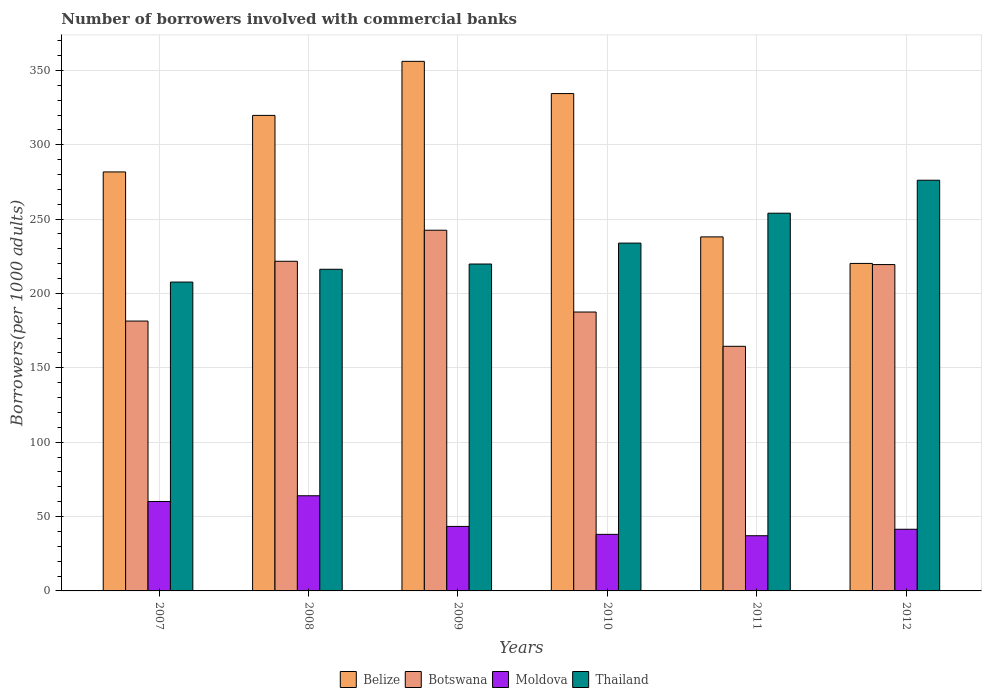How many groups of bars are there?
Your response must be concise. 6. Are the number of bars per tick equal to the number of legend labels?
Ensure brevity in your answer.  Yes. Are the number of bars on each tick of the X-axis equal?
Provide a short and direct response. Yes. What is the number of borrowers involved with commercial banks in Thailand in 2011?
Offer a terse response. 253.97. Across all years, what is the maximum number of borrowers involved with commercial banks in Belize?
Provide a succinct answer. 356.07. Across all years, what is the minimum number of borrowers involved with commercial banks in Botswana?
Provide a succinct answer. 164.48. In which year was the number of borrowers involved with commercial banks in Botswana maximum?
Your answer should be very brief. 2009. What is the total number of borrowers involved with commercial banks in Moldova in the graph?
Give a very brief answer. 284.11. What is the difference between the number of borrowers involved with commercial banks in Botswana in 2011 and that in 2012?
Provide a short and direct response. -54.96. What is the difference between the number of borrowers involved with commercial banks in Belize in 2008 and the number of borrowers involved with commercial banks in Moldova in 2009?
Provide a succinct answer. 276.36. What is the average number of borrowers involved with commercial banks in Thailand per year?
Ensure brevity in your answer.  234.62. In the year 2009, what is the difference between the number of borrowers involved with commercial banks in Botswana and number of borrowers involved with commercial banks in Moldova?
Ensure brevity in your answer.  199.15. What is the ratio of the number of borrowers involved with commercial banks in Thailand in 2009 to that in 2010?
Give a very brief answer. 0.94. What is the difference between the highest and the second highest number of borrowers involved with commercial banks in Moldova?
Ensure brevity in your answer.  3.86. What is the difference between the highest and the lowest number of borrowers involved with commercial banks in Botswana?
Make the answer very short. 78.04. In how many years, is the number of borrowers involved with commercial banks in Thailand greater than the average number of borrowers involved with commercial banks in Thailand taken over all years?
Keep it short and to the point. 2. Is it the case that in every year, the sum of the number of borrowers involved with commercial banks in Botswana and number of borrowers involved with commercial banks in Thailand is greater than the sum of number of borrowers involved with commercial banks in Belize and number of borrowers involved with commercial banks in Moldova?
Your answer should be very brief. Yes. What does the 1st bar from the left in 2009 represents?
Your response must be concise. Belize. What does the 1st bar from the right in 2010 represents?
Provide a short and direct response. Thailand. Are all the bars in the graph horizontal?
Give a very brief answer. No. How many years are there in the graph?
Provide a succinct answer. 6. Are the values on the major ticks of Y-axis written in scientific E-notation?
Offer a terse response. No. Does the graph contain any zero values?
Keep it short and to the point. No. What is the title of the graph?
Offer a terse response. Number of borrowers involved with commercial banks. Does "Bosnia and Herzegovina" appear as one of the legend labels in the graph?
Keep it short and to the point. No. What is the label or title of the Y-axis?
Give a very brief answer. Borrowers(per 1000 adults). What is the Borrowers(per 1000 adults) of Belize in 2007?
Keep it short and to the point. 281.72. What is the Borrowers(per 1000 adults) of Botswana in 2007?
Provide a succinct answer. 181.45. What is the Borrowers(per 1000 adults) of Moldova in 2007?
Provide a succinct answer. 60.13. What is the Borrowers(per 1000 adults) in Thailand in 2007?
Make the answer very short. 207.67. What is the Borrowers(per 1000 adults) in Belize in 2008?
Give a very brief answer. 319.74. What is the Borrowers(per 1000 adults) of Botswana in 2008?
Give a very brief answer. 221.65. What is the Borrowers(per 1000 adults) in Moldova in 2008?
Offer a very short reply. 63.99. What is the Borrowers(per 1000 adults) of Thailand in 2008?
Keep it short and to the point. 216.28. What is the Borrowers(per 1000 adults) in Belize in 2009?
Keep it short and to the point. 356.07. What is the Borrowers(per 1000 adults) of Botswana in 2009?
Ensure brevity in your answer.  242.52. What is the Borrowers(per 1000 adults) in Moldova in 2009?
Your answer should be very brief. 43.38. What is the Borrowers(per 1000 adults) of Thailand in 2009?
Your response must be concise. 219.81. What is the Borrowers(per 1000 adults) in Belize in 2010?
Give a very brief answer. 334.41. What is the Borrowers(per 1000 adults) of Botswana in 2010?
Provide a short and direct response. 187.53. What is the Borrowers(per 1000 adults) in Moldova in 2010?
Offer a very short reply. 38.03. What is the Borrowers(per 1000 adults) of Thailand in 2010?
Provide a short and direct response. 233.87. What is the Borrowers(per 1000 adults) in Belize in 2011?
Make the answer very short. 238.05. What is the Borrowers(per 1000 adults) of Botswana in 2011?
Provide a short and direct response. 164.48. What is the Borrowers(per 1000 adults) in Moldova in 2011?
Provide a succinct answer. 37.11. What is the Borrowers(per 1000 adults) of Thailand in 2011?
Provide a succinct answer. 253.97. What is the Borrowers(per 1000 adults) in Belize in 2012?
Your answer should be compact. 220.2. What is the Borrowers(per 1000 adults) in Botswana in 2012?
Your response must be concise. 219.44. What is the Borrowers(per 1000 adults) of Moldova in 2012?
Make the answer very short. 41.47. What is the Borrowers(per 1000 adults) of Thailand in 2012?
Your answer should be very brief. 276.15. Across all years, what is the maximum Borrowers(per 1000 adults) in Belize?
Provide a short and direct response. 356.07. Across all years, what is the maximum Borrowers(per 1000 adults) in Botswana?
Give a very brief answer. 242.52. Across all years, what is the maximum Borrowers(per 1000 adults) in Moldova?
Offer a very short reply. 63.99. Across all years, what is the maximum Borrowers(per 1000 adults) in Thailand?
Ensure brevity in your answer.  276.15. Across all years, what is the minimum Borrowers(per 1000 adults) of Belize?
Offer a very short reply. 220.2. Across all years, what is the minimum Borrowers(per 1000 adults) in Botswana?
Give a very brief answer. 164.48. Across all years, what is the minimum Borrowers(per 1000 adults) of Moldova?
Provide a succinct answer. 37.11. Across all years, what is the minimum Borrowers(per 1000 adults) in Thailand?
Offer a very short reply. 207.67. What is the total Borrowers(per 1000 adults) of Belize in the graph?
Keep it short and to the point. 1750.19. What is the total Borrowers(per 1000 adults) of Botswana in the graph?
Provide a short and direct response. 1217.07. What is the total Borrowers(per 1000 adults) of Moldova in the graph?
Your answer should be compact. 284.11. What is the total Borrowers(per 1000 adults) of Thailand in the graph?
Keep it short and to the point. 1407.74. What is the difference between the Borrowers(per 1000 adults) in Belize in 2007 and that in 2008?
Keep it short and to the point. -38.02. What is the difference between the Borrowers(per 1000 adults) of Botswana in 2007 and that in 2008?
Provide a short and direct response. -40.2. What is the difference between the Borrowers(per 1000 adults) of Moldova in 2007 and that in 2008?
Make the answer very short. -3.86. What is the difference between the Borrowers(per 1000 adults) in Thailand in 2007 and that in 2008?
Give a very brief answer. -8.6. What is the difference between the Borrowers(per 1000 adults) in Belize in 2007 and that in 2009?
Offer a terse response. -74.35. What is the difference between the Borrowers(per 1000 adults) of Botswana in 2007 and that in 2009?
Offer a terse response. -61.07. What is the difference between the Borrowers(per 1000 adults) of Moldova in 2007 and that in 2009?
Keep it short and to the point. 16.76. What is the difference between the Borrowers(per 1000 adults) of Thailand in 2007 and that in 2009?
Your answer should be very brief. -12.13. What is the difference between the Borrowers(per 1000 adults) of Belize in 2007 and that in 2010?
Your response must be concise. -52.68. What is the difference between the Borrowers(per 1000 adults) in Botswana in 2007 and that in 2010?
Offer a very short reply. -6.07. What is the difference between the Borrowers(per 1000 adults) of Moldova in 2007 and that in 2010?
Provide a short and direct response. 22.1. What is the difference between the Borrowers(per 1000 adults) of Thailand in 2007 and that in 2010?
Your answer should be compact. -26.2. What is the difference between the Borrowers(per 1000 adults) in Belize in 2007 and that in 2011?
Offer a terse response. 43.68. What is the difference between the Borrowers(per 1000 adults) in Botswana in 2007 and that in 2011?
Make the answer very short. 16.97. What is the difference between the Borrowers(per 1000 adults) of Moldova in 2007 and that in 2011?
Your response must be concise. 23.02. What is the difference between the Borrowers(per 1000 adults) of Thailand in 2007 and that in 2011?
Your answer should be compact. -46.3. What is the difference between the Borrowers(per 1000 adults) in Belize in 2007 and that in 2012?
Your answer should be very brief. 61.52. What is the difference between the Borrowers(per 1000 adults) in Botswana in 2007 and that in 2012?
Your answer should be very brief. -37.99. What is the difference between the Borrowers(per 1000 adults) of Moldova in 2007 and that in 2012?
Provide a short and direct response. 18.67. What is the difference between the Borrowers(per 1000 adults) in Thailand in 2007 and that in 2012?
Ensure brevity in your answer.  -68.48. What is the difference between the Borrowers(per 1000 adults) in Belize in 2008 and that in 2009?
Offer a very short reply. -36.33. What is the difference between the Borrowers(per 1000 adults) in Botswana in 2008 and that in 2009?
Provide a succinct answer. -20.87. What is the difference between the Borrowers(per 1000 adults) in Moldova in 2008 and that in 2009?
Your answer should be compact. 20.61. What is the difference between the Borrowers(per 1000 adults) of Thailand in 2008 and that in 2009?
Provide a succinct answer. -3.53. What is the difference between the Borrowers(per 1000 adults) in Belize in 2008 and that in 2010?
Make the answer very short. -14.67. What is the difference between the Borrowers(per 1000 adults) of Botswana in 2008 and that in 2010?
Offer a very short reply. 34.12. What is the difference between the Borrowers(per 1000 adults) in Moldova in 2008 and that in 2010?
Make the answer very short. 25.95. What is the difference between the Borrowers(per 1000 adults) in Thailand in 2008 and that in 2010?
Provide a succinct answer. -17.59. What is the difference between the Borrowers(per 1000 adults) of Belize in 2008 and that in 2011?
Your answer should be very brief. 81.69. What is the difference between the Borrowers(per 1000 adults) in Botswana in 2008 and that in 2011?
Give a very brief answer. 57.17. What is the difference between the Borrowers(per 1000 adults) of Moldova in 2008 and that in 2011?
Offer a very short reply. 26.87. What is the difference between the Borrowers(per 1000 adults) of Thailand in 2008 and that in 2011?
Keep it short and to the point. -37.7. What is the difference between the Borrowers(per 1000 adults) of Belize in 2008 and that in 2012?
Make the answer very short. 99.53. What is the difference between the Borrowers(per 1000 adults) of Botswana in 2008 and that in 2012?
Give a very brief answer. 2.21. What is the difference between the Borrowers(per 1000 adults) in Moldova in 2008 and that in 2012?
Make the answer very short. 22.52. What is the difference between the Borrowers(per 1000 adults) of Thailand in 2008 and that in 2012?
Give a very brief answer. -59.87. What is the difference between the Borrowers(per 1000 adults) of Belize in 2009 and that in 2010?
Offer a terse response. 21.67. What is the difference between the Borrowers(per 1000 adults) of Botswana in 2009 and that in 2010?
Your answer should be compact. 55. What is the difference between the Borrowers(per 1000 adults) of Moldova in 2009 and that in 2010?
Provide a short and direct response. 5.34. What is the difference between the Borrowers(per 1000 adults) in Thailand in 2009 and that in 2010?
Provide a short and direct response. -14.06. What is the difference between the Borrowers(per 1000 adults) in Belize in 2009 and that in 2011?
Offer a terse response. 118.03. What is the difference between the Borrowers(per 1000 adults) in Botswana in 2009 and that in 2011?
Offer a terse response. 78.04. What is the difference between the Borrowers(per 1000 adults) of Moldova in 2009 and that in 2011?
Your answer should be very brief. 6.26. What is the difference between the Borrowers(per 1000 adults) in Thailand in 2009 and that in 2011?
Your answer should be compact. -34.17. What is the difference between the Borrowers(per 1000 adults) of Belize in 2009 and that in 2012?
Your answer should be very brief. 135.87. What is the difference between the Borrowers(per 1000 adults) of Botswana in 2009 and that in 2012?
Provide a short and direct response. 23.08. What is the difference between the Borrowers(per 1000 adults) of Moldova in 2009 and that in 2012?
Keep it short and to the point. 1.91. What is the difference between the Borrowers(per 1000 adults) of Thailand in 2009 and that in 2012?
Provide a short and direct response. -56.34. What is the difference between the Borrowers(per 1000 adults) in Belize in 2010 and that in 2011?
Your response must be concise. 96.36. What is the difference between the Borrowers(per 1000 adults) in Botswana in 2010 and that in 2011?
Keep it short and to the point. 23.05. What is the difference between the Borrowers(per 1000 adults) in Moldova in 2010 and that in 2011?
Make the answer very short. 0.92. What is the difference between the Borrowers(per 1000 adults) of Thailand in 2010 and that in 2011?
Your answer should be compact. -20.1. What is the difference between the Borrowers(per 1000 adults) of Belize in 2010 and that in 2012?
Provide a succinct answer. 114.2. What is the difference between the Borrowers(per 1000 adults) in Botswana in 2010 and that in 2012?
Provide a succinct answer. -31.91. What is the difference between the Borrowers(per 1000 adults) in Moldova in 2010 and that in 2012?
Give a very brief answer. -3.43. What is the difference between the Borrowers(per 1000 adults) in Thailand in 2010 and that in 2012?
Give a very brief answer. -42.28. What is the difference between the Borrowers(per 1000 adults) in Belize in 2011 and that in 2012?
Offer a very short reply. 17.84. What is the difference between the Borrowers(per 1000 adults) of Botswana in 2011 and that in 2012?
Make the answer very short. -54.96. What is the difference between the Borrowers(per 1000 adults) in Moldova in 2011 and that in 2012?
Offer a terse response. -4.35. What is the difference between the Borrowers(per 1000 adults) in Thailand in 2011 and that in 2012?
Ensure brevity in your answer.  -22.18. What is the difference between the Borrowers(per 1000 adults) in Belize in 2007 and the Borrowers(per 1000 adults) in Botswana in 2008?
Keep it short and to the point. 60.07. What is the difference between the Borrowers(per 1000 adults) of Belize in 2007 and the Borrowers(per 1000 adults) of Moldova in 2008?
Offer a terse response. 217.73. What is the difference between the Borrowers(per 1000 adults) in Belize in 2007 and the Borrowers(per 1000 adults) in Thailand in 2008?
Make the answer very short. 65.45. What is the difference between the Borrowers(per 1000 adults) of Botswana in 2007 and the Borrowers(per 1000 adults) of Moldova in 2008?
Make the answer very short. 117.46. What is the difference between the Borrowers(per 1000 adults) of Botswana in 2007 and the Borrowers(per 1000 adults) of Thailand in 2008?
Your response must be concise. -34.82. What is the difference between the Borrowers(per 1000 adults) in Moldova in 2007 and the Borrowers(per 1000 adults) in Thailand in 2008?
Your answer should be very brief. -156.14. What is the difference between the Borrowers(per 1000 adults) in Belize in 2007 and the Borrowers(per 1000 adults) in Botswana in 2009?
Your response must be concise. 39.2. What is the difference between the Borrowers(per 1000 adults) in Belize in 2007 and the Borrowers(per 1000 adults) in Moldova in 2009?
Give a very brief answer. 238.35. What is the difference between the Borrowers(per 1000 adults) in Belize in 2007 and the Borrowers(per 1000 adults) in Thailand in 2009?
Offer a terse response. 61.92. What is the difference between the Borrowers(per 1000 adults) in Botswana in 2007 and the Borrowers(per 1000 adults) in Moldova in 2009?
Your response must be concise. 138.08. What is the difference between the Borrowers(per 1000 adults) of Botswana in 2007 and the Borrowers(per 1000 adults) of Thailand in 2009?
Your answer should be very brief. -38.35. What is the difference between the Borrowers(per 1000 adults) of Moldova in 2007 and the Borrowers(per 1000 adults) of Thailand in 2009?
Ensure brevity in your answer.  -159.67. What is the difference between the Borrowers(per 1000 adults) in Belize in 2007 and the Borrowers(per 1000 adults) in Botswana in 2010?
Your answer should be very brief. 94.2. What is the difference between the Borrowers(per 1000 adults) in Belize in 2007 and the Borrowers(per 1000 adults) in Moldova in 2010?
Make the answer very short. 243.69. What is the difference between the Borrowers(per 1000 adults) in Belize in 2007 and the Borrowers(per 1000 adults) in Thailand in 2010?
Provide a short and direct response. 47.85. What is the difference between the Borrowers(per 1000 adults) in Botswana in 2007 and the Borrowers(per 1000 adults) in Moldova in 2010?
Keep it short and to the point. 143.42. What is the difference between the Borrowers(per 1000 adults) of Botswana in 2007 and the Borrowers(per 1000 adults) of Thailand in 2010?
Make the answer very short. -52.42. What is the difference between the Borrowers(per 1000 adults) in Moldova in 2007 and the Borrowers(per 1000 adults) in Thailand in 2010?
Provide a short and direct response. -173.74. What is the difference between the Borrowers(per 1000 adults) of Belize in 2007 and the Borrowers(per 1000 adults) of Botswana in 2011?
Your answer should be very brief. 117.24. What is the difference between the Borrowers(per 1000 adults) of Belize in 2007 and the Borrowers(per 1000 adults) of Moldova in 2011?
Offer a very short reply. 244.61. What is the difference between the Borrowers(per 1000 adults) in Belize in 2007 and the Borrowers(per 1000 adults) in Thailand in 2011?
Your response must be concise. 27.75. What is the difference between the Borrowers(per 1000 adults) in Botswana in 2007 and the Borrowers(per 1000 adults) in Moldova in 2011?
Give a very brief answer. 144.34. What is the difference between the Borrowers(per 1000 adults) of Botswana in 2007 and the Borrowers(per 1000 adults) of Thailand in 2011?
Provide a succinct answer. -72.52. What is the difference between the Borrowers(per 1000 adults) in Moldova in 2007 and the Borrowers(per 1000 adults) in Thailand in 2011?
Your answer should be very brief. -193.84. What is the difference between the Borrowers(per 1000 adults) in Belize in 2007 and the Borrowers(per 1000 adults) in Botswana in 2012?
Ensure brevity in your answer.  62.28. What is the difference between the Borrowers(per 1000 adults) in Belize in 2007 and the Borrowers(per 1000 adults) in Moldova in 2012?
Your answer should be very brief. 240.26. What is the difference between the Borrowers(per 1000 adults) of Belize in 2007 and the Borrowers(per 1000 adults) of Thailand in 2012?
Offer a very short reply. 5.57. What is the difference between the Borrowers(per 1000 adults) of Botswana in 2007 and the Borrowers(per 1000 adults) of Moldova in 2012?
Make the answer very short. 139.99. What is the difference between the Borrowers(per 1000 adults) in Botswana in 2007 and the Borrowers(per 1000 adults) in Thailand in 2012?
Ensure brevity in your answer.  -94.7. What is the difference between the Borrowers(per 1000 adults) in Moldova in 2007 and the Borrowers(per 1000 adults) in Thailand in 2012?
Offer a terse response. -216.01. What is the difference between the Borrowers(per 1000 adults) in Belize in 2008 and the Borrowers(per 1000 adults) in Botswana in 2009?
Make the answer very short. 77.22. What is the difference between the Borrowers(per 1000 adults) of Belize in 2008 and the Borrowers(per 1000 adults) of Moldova in 2009?
Ensure brevity in your answer.  276.36. What is the difference between the Borrowers(per 1000 adults) in Belize in 2008 and the Borrowers(per 1000 adults) in Thailand in 2009?
Offer a terse response. 99.93. What is the difference between the Borrowers(per 1000 adults) of Botswana in 2008 and the Borrowers(per 1000 adults) of Moldova in 2009?
Provide a short and direct response. 178.27. What is the difference between the Borrowers(per 1000 adults) in Botswana in 2008 and the Borrowers(per 1000 adults) in Thailand in 2009?
Provide a short and direct response. 1.84. What is the difference between the Borrowers(per 1000 adults) of Moldova in 2008 and the Borrowers(per 1000 adults) of Thailand in 2009?
Make the answer very short. -155.82. What is the difference between the Borrowers(per 1000 adults) of Belize in 2008 and the Borrowers(per 1000 adults) of Botswana in 2010?
Your response must be concise. 132.21. What is the difference between the Borrowers(per 1000 adults) of Belize in 2008 and the Borrowers(per 1000 adults) of Moldova in 2010?
Ensure brevity in your answer.  281.7. What is the difference between the Borrowers(per 1000 adults) of Belize in 2008 and the Borrowers(per 1000 adults) of Thailand in 2010?
Make the answer very short. 85.87. What is the difference between the Borrowers(per 1000 adults) in Botswana in 2008 and the Borrowers(per 1000 adults) in Moldova in 2010?
Give a very brief answer. 183.62. What is the difference between the Borrowers(per 1000 adults) of Botswana in 2008 and the Borrowers(per 1000 adults) of Thailand in 2010?
Give a very brief answer. -12.22. What is the difference between the Borrowers(per 1000 adults) in Moldova in 2008 and the Borrowers(per 1000 adults) in Thailand in 2010?
Offer a terse response. -169.88. What is the difference between the Borrowers(per 1000 adults) in Belize in 2008 and the Borrowers(per 1000 adults) in Botswana in 2011?
Provide a succinct answer. 155.26. What is the difference between the Borrowers(per 1000 adults) of Belize in 2008 and the Borrowers(per 1000 adults) of Moldova in 2011?
Make the answer very short. 282.62. What is the difference between the Borrowers(per 1000 adults) in Belize in 2008 and the Borrowers(per 1000 adults) in Thailand in 2011?
Ensure brevity in your answer.  65.77. What is the difference between the Borrowers(per 1000 adults) in Botswana in 2008 and the Borrowers(per 1000 adults) in Moldova in 2011?
Keep it short and to the point. 184.54. What is the difference between the Borrowers(per 1000 adults) in Botswana in 2008 and the Borrowers(per 1000 adults) in Thailand in 2011?
Provide a succinct answer. -32.32. What is the difference between the Borrowers(per 1000 adults) of Moldova in 2008 and the Borrowers(per 1000 adults) of Thailand in 2011?
Your answer should be compact. -189.98. What is the difference between the Borrowers(per 1000 adults) of Belize in 2008 and the Borrowers(per 1000 adults) of Botswana in 2012?
Your answer should be very brief. 100.3. What is the difference between the Borrowers(per 1000 adults) of Belize in 2008 and the Borrowers(per 1000 adults) of Moldova in 2012?
Your answer should be very brief. 278.27. What is the difference between the Borrowers(per 1000 adults) in Belize in 2008 and the Borrowers(per 1000 adults) in Thailand in 2012?
Ensure brevity in your answer.  43.59. What is the difference between the Borrowers(per 1000 adults) in Botswana in 2008 and the Borrowers(per 1000 adults) in Moldova in 2012?
Give a very brief answer. 180.18. What is the difference between the Borrowers(per 1000 adults) of Botswana in 2008 and the Borrowers(per 1000 adults) of Thailand in 2012?
Offer a very short reply. -54.5. What is the difference between the Borrowers(per 1000 adults) of Moldova in 2008 and the Borrowers(per 1000 adults) of Thailand in 2012?
Offer a very short reply. -212.16. What is the difference between the Borrowers(per 1000 adults) in Belize in 2009 and the Borrowers(per 1000 adults) in Botswana in 2010?
Give a very brief answer. 168.54. What is the difference between the Borrowers(per 1000 adults) of Belize in 2009 and the Borrowers(per 1000 adults) of Moldova in 2010?
Ensure brevity in your answer.  318.04. What is the difference between the Borrowers(per 1000 adults) of Belize in 2009 and the Borrowers(per 1000 adults) of Thailand in 2010?
Your answer should be very brief. 122.2. What is the difference between the Borrowers(per 1000 adults) of Botswana in 2009 and the Borrowers(per 1000 adults) of Moldova in 2010?
Keep it short and to the point. 204.49. What is the difference between the Borrowers(per 1000 adults) in Botswana in 2009 and the Borrowers(per 1000 adults) in Thailand in 2010?
Your answer should be very brief. 8.65. What is the difference between the Borrowers(per 1000 adults) in Moldova in 2009 and the Borrowers(per 1000 adults) in Thailand in 2010?
Offer a terse response. -190.49. What is the difference between the Borrowers(per 1000 adults) in Belize in 2009 and the Borrowers(per 1000 adults) in Botswana in 2011?
Your answer should be very brief. 191.59. What is the difference between the Borrowers(per 1000 adults) in Belize in 2009 and the Borrowers(per 1000 adults) in Moldova in 2011?
Give a very brief answer. 318.96. What is the difference between the Borrowers(per 1000 adults) in Belize in 2009 and the Borrowers(per 1000 adults) in Thailand in 2011?
Offer a very short reply. 102.1. What is the difference between the Borrowers(per 1000 adults) of Botswana in 2009 and the Borrowers(per 1000 adults) of Moldova in 2011?
Your answer should be compact. 205.41. What is the difference between the Borrowers(per 1000 adults) in Botswana in 2009 and the Borrowers(per 1000 adults) in Thailand in 2011?
Your answer should be very brief. -11.45. What is the difference between the Borrowers(per 1000 adults) in Moldova in 2009 and the Borrowers(per 1000 adults) in Thailand in 2011?
Offer a very short reply. -210.59. What is the difference between the Borrowers(per 1000 adults) in Belize in 2009 and the Borrowers(per 1000 adults) in Botswana in 2012?
Provide a succinct answer. 136.63. What is the difference between the Borrowers(per 1000 adults) in Belize in 2009 and the Borrowers(per 1000 adults) in Moldova in 2012?
Keep it short and to the point. 314.61. What is the difference between the Borrowers(per 1000 adults) of Belize in 2009 and the Borrowers(per 1000 adults) of Thailand in 2012?
Make the answer very short. 79.92. What is the difference between the Borrowers(per 1000 adults) in Botswana in 2009 and the Borrowers(per 1000 adults) in Moldova in 2012?
Ensure brevity in your answer.  201.06. What is the difference between the Borrowers(per 1000 adults) of Botswana in 2009 and the Borrowers(per 1000 adults) of Thailand in 2012?
Ensure brevity in your answer.  -33.63. What is the difference between the Borrowers(per 1000 adults) of Moldova in 2009 and the Borrowers(per 1000 adults) of Thailand in 2012?
Provide a short and direct response. -232.77. What is the difference between the Borrowers(per 1000 adults) of Belize in 2010 and the Borrowers(per 1000 adults) of Botswana in 2011?
Provide a succinct answer. 169.93. What is the difference between the Borrowers(per 1000 adults) in Belize in 2010 and the Borrowers(per 1000 adults) in Moldova in 2011?
Keep it short and to the point. 297.29. What is the difference between the Borrowers(per 1000 adults) of Belize in 2010 and the Borrowers(per 1000 adults) of Thailand in 2011?
Ensure brevity in your answer.  80.43. What is the difference between the Borrowers(per 1000 adults) in Botswana in 2010 and the Borrowers(per 1000 adults) in Moldova in 2011?
Keep it short and to the point. 150.41. What is the difference between the Borrowers(per 1000 adults) of Botswana in 2010 and the Borrowers(per 1000 adults) of Thailand in 2011?
Offer a terse response. -66.44. What is the difference between the Borrowers(per 1000 adults) in Moldova in 2010 and the Borrowers(per 1000 adults) in Thailand in 2011?
Keep it short and to the point. -215.94. What is the difference between the Borrowers(per 1000 adults) of Belize in 2010 and the Borrowers(per 1000 adults) of Botswana in 2012?
Give a very brief answer. 114.97. What is the difference between the Borrowers(per 1000 adults) of Belize in 2010 and the Borrowers(per 1000 adults) of Moldova in 2012?
Provide a short and direct response. 292.94. What is the difference between the Borrowers(per 1000 adults) of Belize in 2010 and the Borrowers(per 1000 adults) of Thailand in 2012?
Ensure brevity in your answer.  58.26. What is the difference between the Borrowers(per 1000 adults) in Botswana in 2010 and the Borrowers(per 1000 adults) in Moldova in 2012?
Offer a very short reply. 146.06. What is the difference between the Borrowers(per 1000 adults) of Botswana in 2010 and the Borrowers(per 1000 adults) of Thailand in 2012?
Provide a succinct answer. -88.62. What is the difference between the Borrowers(per 1000 adults) in Moldova in 2010 and the Borrowers(per 1000 adults) in Thailand in 2012?
Make the answer very short. -238.11. What is the difference between the Borrowers(per 1000 adults) of Belize in 2011 and the Borrowers(per 1000 adults) of Botswana in 2012?
Offer a very short reply. 18.61. What is the difference between the Borrowers(per 1000 adults) of Belize in 2011 and the Borrowers(per 1000 adults) of Moldova in 2012?
Provide a succinct answer. 196.58. What is the difference between the Borrowers(per 1000 adults) of Belize in 2011 and the Borrowers(per 1000 adults) of Thailand in 2012?
Make the answer very short. -38.1. What is the difference between the Borrowers(per 1000 adults) in Botswana in 2011 and the Borrowers(per 1000 adults) in Moldova in 2012?
Offer a terse response. 123.01. What is the difference between the Borrowers(per 1000 adults) in Botswana in 2011 and the Borrowers(per 1000 adults) in Thailand in 2012?
Ensure brevity in your answer.  -111.67. What is the difference between the Borrowers(per 1000 adults) of Moldova in 2011 and the Borrowers(per 1000 adults) of Thailand in 2012?
Give a very brief answer. -239.03. What is the average Borrowers(per 1000 adults) in Belize per year?
Give a very brief answer. 291.7. What is the average Borrowers(per 1000 adults) of Botswana per year?
Your response must be concise. 202.84. What is the average Borrowers(per 1000 adults) of Moldova per year?
Provide a short and direct response. 47.35. What is the average Borrowers(per 1000 adults) in Thailand per year?
Provide a short and direct response. 234.62. In the year 2007, what is the difference between the Borrowers(per 1000 adults) in Belize and Borrowers(per 1000 adults) in Botswana?
Offer a terse response. 100.27. In the year 2007, what is the difference between the Borrowers(per 1000 adults) of Belize and Borrowers(per 1000 adults) of Moldova?
Provide a succinct answer. 221.59. In the year 2007, what is the difference between the Borrowers(per 1000 adults) of Belize and Borrowers(per 1000 adults) of Thailand?
Provide a short and direct response. 74.05. In the year 2007, what is the difference between the Borrowers(per 1000 adults) of Botswana and Borrowers(per 1000 adults) of Moldova?
Your answer should be very brief. 121.32. In the year 2007, what is the difference between the Borrowers(per 1000 adults) in Botswana and Borrowers(per 1000 adults) in Thailand?
Give a very brief answer. -26.22. In the year 2007, what is the difference between the Borrowers(per 1000 adults) in Moldova and Borrowers(per 1000 adults) in Thailand?
Give a very brief answer. -147.54. In the year 2008, what is the difference between the Borrowers(per 1000 adults) in Belize and Borrowers(per 1000 adults) in Botswana?
Your answer should be compact. 98.09. In the year 2008, what is the difference between the Borrowers(per 1000 adults) of Belize and Borrowers(per 1000 adults) of Moldova?
Your answer should be very brief. 255.75. In the year 2008, what is the difference between the Borrowers(per 1000 adults) in Belize and Borrowers(per 1000 adults) in Thailand?
Keep it short and to the point. 103.46. In the year 2008, what is the difference between the Borrowers(per 1000 adults) of Botswana and Borrowers(per 1000 adults) of Moldova?
Your answer should be very brief. 157.66. In the year 2008, what is the difference between the Borrowers(per 1000 adults) in Botswana and Borrowers(per 1000 adults) in Thailand?
Your response must be concise. 5.37. In the year 2008, what is the difference between the Borrowers(per 1000 adults) in Moldova and Borrowers(per 1000 adults) in Thailand?
Offer a very short reply. -152.29. In the year 2009, what is the difference between the Borrowers(per 1000 adults) of Belize and Borrowers(per 1000 adults) of Botswana?
Offer a terse response. 113.55. In the year 2009, what is the difference between the Borrowers(per 1000 adults) of Belize and Borrowers(per 1000 adults) of Moldova?
Your response must be concise. 312.69. In the year 2009, what is the difference between the Borrowers(per 1000 adults) in Belize and Borrowers(per 1000 adults) in Thailand?
Provide a short and direct response. 136.27. In the year 2009, what is the difference between the Borrowers(per 1000 adults) in Botswana and Borrowers(per 1000 adults) in Moldova?
Make the answer very short. 199.15. In the year 2009, what is the difference between the Borrowers(per 1000 adults) of Botswana and Borrowers(per 1000 adults) of Thailand?
Offer a terse response. 22.72. In the year 2009, what is the difference between the Borrowers(per 1000 adults) of Moldova and Borrowers(per 1000 adults) of Thailand?
Make the answer very short. -176.43. In the year 2010, what is the difference between the Borrowers(per 1000 adults) of Belize and Borrowers(per 1000 adults) of Botswana?
Ensure brevity in your answer.  146.88. In the year 2010, what is the difference between the Borrowers(per 1000 adults) of Belize and Borrowers(per 1000 adults) of Moldova?
Your answer should be very brief. 296.37. In the year 2010, what is the difference between the Borrowers(per 1000 adults) in Belize and Borrowers(per 1000 adults) in Thailand?
Offer a terse response. 100.54. In the year 2010, what is the difference between the Borrowers(per 1000 adults) of Botswana and Borrowers(per 1000 adults) of Moldova?
Provide a short and direct response. 149.49. In the year 2010, what is the difference between the Borrowers(per 1000 adults) in Botswana and Borrowers(per 1000 adults) in Thailand?
Make the answer very short. -46.34. In the year 2010, what is the difference between the Borrowers(per 1000 adults) in Moldova and Borrowers(per 1000 adults) in Thailand?
Keep it short and to the point. -195.83. In the year 2011, what is the difference between the Borrowers(per 1000 adults) of Belize and Borrowers(per 1000 adults) of Botswana?
Provide a succinct answer. 73.57. In the year 2011, what is the difference between the Borrowers(per 1000 adults) of Belize and Borrowers(per 1000 adults) of Moldova?
Keep it short and to the point. 200.93. In the year 2011, what is the difference between the Borrowers(per 1000 adults) in Belize and Borrowers(per 1000 adults) in Thailand?
Ensure brevity in your answer.  -15.93. In the year 2011, what is the difference between the Borrowers(per 1000 adults) of Botswana and Borrowers(per 1000 adults) of Moldova?
Offer a very short reply. 127.36. In the year 2011, what is the difference between the Borrowers(per 1000 adults) of Botswana and Borrowers(per 1000 adults) of Thailand?
Make the answer very short. -89.49. In the year 2011, what is the difference between the Borrowers(per 1000 adults) of Moldova and Borrowers(per 1000 adults) of Thailand?
Make the answer very short. -216.86. In the year 2012, what is the difference between the Borrowers(per 1000 adults) of Belize and Borrowers(per 1000 adults) of Botswana?
Offer a very short reply. 0.77. In the year 2012, what is the difference between the Borrowers(per 1000 adults) in Belize and Borrowers(per 1000 adults) in Moldova?
Your answer should be compact. 178.74. In the year 2012, what is the difference between the Borrowers(per 1000 adults) in Belize and Borrowers(per 1000 adults) in Thailand?
Keep it short and to the point. -55.94. In the year 2012, what is the difference between the Borrowers(per 1000 adults) of Botswana and Borrowers(per 1000 adults) of Moldova?
Offer a very short reply. 177.97. In the year 2012, what is the difference between the Borrowers(per 1000 adults) in Botswana and Borrowers(per 1000 adults) in Thailand?
Offer a very short reply. -56.71. In the year 2012, what is the difference between the Borrowers(per 1000 adults) of Moldova and Borrowers(per 1000 adults) of Thailand?
Offer a terse response. -234.68. What is the ratio of the Borrowers(per 1000 adults) in Belize in 2007 to that in 2008?
Your answer should be very brief. 0.88. What is the ratio of the Borrowers(per 1000 adults) in Botswana in 2007 to that in 2008?
Offer a terse response. 0.82. What is the ratio of the Borrowers(per 1000 adults) of Moldova in 2007 to that in 2008?
Ensure brevity in your answer.  0.94. What is the ratio of the Borrowers(per 1000 adults) of Thailand in 2007 to that in 2008?
Your response must be concise. 0.96. What is the ratio of the Borrowers(per 1000 adults) of Belize in 2007 to that in 2009?
Offer a very short reply. 0.79. What is the ratio of the Borrowers(per 1000 adults) of Botswana in 2007 to that in 2009?
Offer a very short reply. 0.75. What is the ratio of the Borrowers(per 1000 adults) of Moldova in 2007 to that in 2009?
Offer a terse response. 1.39. What is the ratio of the Borrowers(per 1000 adults) of Thailand in 2007 to that in 2009?
Make the answer very short. 0.94. What is the ratio of the Borrowers(per 1000 adults) in Belize in 2007 to that in 2010?
Offer a very short reply. 0.84. What is the ratio of the Borrowers(per 1000 adults) of Botswana in 2007 to that in 2010?
Your response must be concise. 0.97. What is the ratio of the Borrowers(per 1000 adults) of Moldova in 2007 to that in 2010?
Keep it short and to the point. 1.58. What is the ratio of the Borrowers(per 1000 adults) in Thailand in 2007 to that in 2010?
Ensure brevity in your answer.  0.89. What is the ratio of the Borrowers(per 1000 adults) in Belize in 2007 to that in 2011?
Give a very brief answer. 1.18. What is the ratio of the Borrowers(per 1000 adults) of Botswana in 2007 to that in 2011?
Your answer should be very brief. 1.1. What is the ratio of the Borrowers(per 1000 adults) of Moldova in 2007 to that in 2011?
Provide a short and direct response. 1.62. What is the ratio of the Borrowers(per 1000 adults) in Thailand in 2007 to that in 2011?
Give a very brief answer. 0.82. What is the ratio of the Borrowers(per 1000 adults) of Belize in 2007 to that in 2012?
Offer a terse response. 1.28. What is the ratio of the Borrowers(per 1000 adults) in Botswana in 2007 to that in 2012?
Ensure brevity in your answer.  0.83. What is the ratio of the Borrowers(per 1000 adults) in Moldova in 2007 to that in 2012?
Provide a short and direct response. 1.45. What is the ratio of the Borrowers(per 1000 adults) of Thailand in 2007 to that in 2012?
Your response must be concise. 0.75. What is the ratio of the Borrowers(per 1000 adults) in Belize in 2008 to that in 2009?
Ensure brevity in your answer.  0.9. What is the ratio of the Borrowers(per 1000 adults) of Botswana in 2008 to that in 2009?
Offer a terse response. 0.91. What is the ratio of the Borrowers(per 1000 adults) of Moldova in 2008 to that in 2009?
Your response must be concise. 1.48. What is the ratio of the Borrowers(per 1000 adults) in Thailand in 2008 to that in 2009?
Your response must be concise. 0.98. What is the ratio of the Borrowers(per 1000 adults) of Belize in 2008 to that in 2010?
Ensure brevity in your answer.  0.96. What is the ratio of the Borrowers(per 1000 adults) in Botswana in 2008 to that in 2010?
Your answer should be compact. 1.18. What is the ratio of the Borrowers(per 1000 adults) of Moldova in 2008 to that in 2010?
Keep it short and to the point. 1.68. What is the ratio of the Borrowers(per 1000 adults) of Thailand in 2008 to that in 2010?
Ensure brevity in your answer.  0.92. What is the ratio of the Borrowers(per 1000 adults) of Belize in 2008 to that in 2011?
Make the answer very short. 1.34. What is the ratio of the Borrowers(per 1000 adults) in Botswana in 2008 to that in 2011?
Ensure brevity in your answer.  1.35. What is the ratio of the Borrowers(per 1000 adults) in Moldova in 2008 to that in 2011?
Your answer should be very brief. 1.72. What is the ratio of the Borrowers(per 1000 adults) of Thailand in 2008 to that in 2011?
Your answer should be very brief. 0.85. What is the ratio of the Borrowers(per 1000 adults) of Belize in 2008 to that in 2012?
Give a very brief answer. 1.45. What is the ratio of the Borrowers(per 1000 adults) of Moldova in 2008 to that in 2012?
Provide a succinct answer. 1.54. What is the ratio of the Borrowers(per 1000 adults) of Thailand in 2008 to that in 2012?
Provide a short and direct response. 0.78. What is the ratio of the Borrowers(per 1000 adults) in Belize in 2009 to that in 2010?
Make the answer very short. 1.06. What is the ratio of the Borrowers(per 1000 adults) in Botswana in 2009 to that in 2010?
Your response must be concise. 1.29. What is the ratio of the Borrowers(per 1000 adults) in Moldova in 2009 to that in 2010?
Your response must be concise. 1.14. What is the ratio of the Borrowers(per 1000 adults) in Thailand in 2009 to that in 2010?
Your answer should be compact. 0.94. What is the ratio of the Borrowers(per 1000 adults) of Belize in 2009 to that in 2011?
Ensure brevity in your answer.  1.5. What is the ratio of the Borrowers(per 1000 adults) in Botswana in 2009 to that in 2011?
Your response must be concise. 1.47. What is the ratio of the Borrowers(per 1000 adults) of Moldova in 2009 to that in 2011?
Provide a succinct answer. 1.17. What is the ratio of the Borrowers(per 1000 adults) of Thailand in 2009 to that in 2011?
Offer a very short reply. 0.87. What is the ratio of the Borrowers(per 1000 adults) in Belize in 2009 to that in 2012?
Offer a terse response. 1.62. What is the ratio of the Borrowers(per 1000 adults) in Botswana in 2009 to that in 2012?
Provide a short and direct response. 1.11. What is the ratio of the Borrowers(per 1000 adults) in Moldova in 2009 to that in 2012?
Offer a terse response. 1.05. What is the ratio of the Borrowers(per 1000 adults) of Thailand in 2009 to that in 2012?
Keep it short and to the point. 0.8. What is the ratio of the Borrowers(per 1000 adults) in Belize in 2010 to that in 2011?
Provide a succinct answer. 1.4. What is the ratio of the Borrowers(per 1000 adults) of Botswana in 2010 to that in 2011?
Make the answer very short. 1.14. What is the ratio of the Borrowers(per 1000 adults) in Moldova in 2010 to that in 2011?
Make the answer very short. 1.02. What is the ratio of the Borrowers(per 1000 adults) in Thailand in 2010 to that in 2011?
Give a very brief answer. 0.92. What is the ratio of the Borrowers(per 1000 adults) in Belize in 2010 to that in 2012?
Offer a terse response. 1.52. What is the ratio of the Borrowers(per 1000 adults) in Botswana in 2010 to that in 2012?
Offer a terse response. 0.85. What is the ratio of the Borrowers(per 1000 adults) in Moldova in 2010 to that in 2012?
Make the answer very short. 0.92. What is the ratio of the Borrowers(per 1000 adults) of Thailand in 2010 to that in 2012?
Your answer should be compact. 0.85. What is the ratio of the Borrowers(per 1000 adults) of Belize in 2011 to that in 2012?
Offer a very short reply. 1.08. What is the ratio of the Borrowers(per 1000 adults) in Botswana in 2011 to that in 2012?
Your answer should be compact. 0.75. What is the ratio of the Borrowers(per 1000 adults) in Moldova in 2011 to that in 2012?
Your answer should be compact. 0.9. What is the ratio of the Borrowers(per 1000 adults) of Thailand in 2011 to that in 2012?
Provide a succinct answer. 0.92. What is the difference between the highest and the second highest Borrowers(per 1000 adults) in Belize?
Your answer should be very brief. 21.67. What is the difference between the highest and the second highest Borrowers(per 1000 adults) in Botswana?
Give a very brief answer. 20.87. What is the difference between the highest and the second highest Borrowers(per 1000 adults) in Moldova?
Provide a short and direct response. 3.86. What is the difference between the highest and the second highest Borrowers(per 1000 adults) of Thailand?
Your response must be concise. 22.18. What is the difference between the highest and the lowest Borrowers(per 1000 adults) in Belize?
Your answer should be very brief. 135.87. What is the difference between the highest and the lowest Borrowers(per 1000 adults) of Botswana?
Your response must be concise. 78.04. What is the difference between the highest and the lowest Borrowers(per 1000 adults) in Moldova?
Offer a very short reply. 26.87. What is the difference between the highest and the lowest Borrowers(per 1000 adults) of Thailand?
Give a very brief answer. 68.48. 